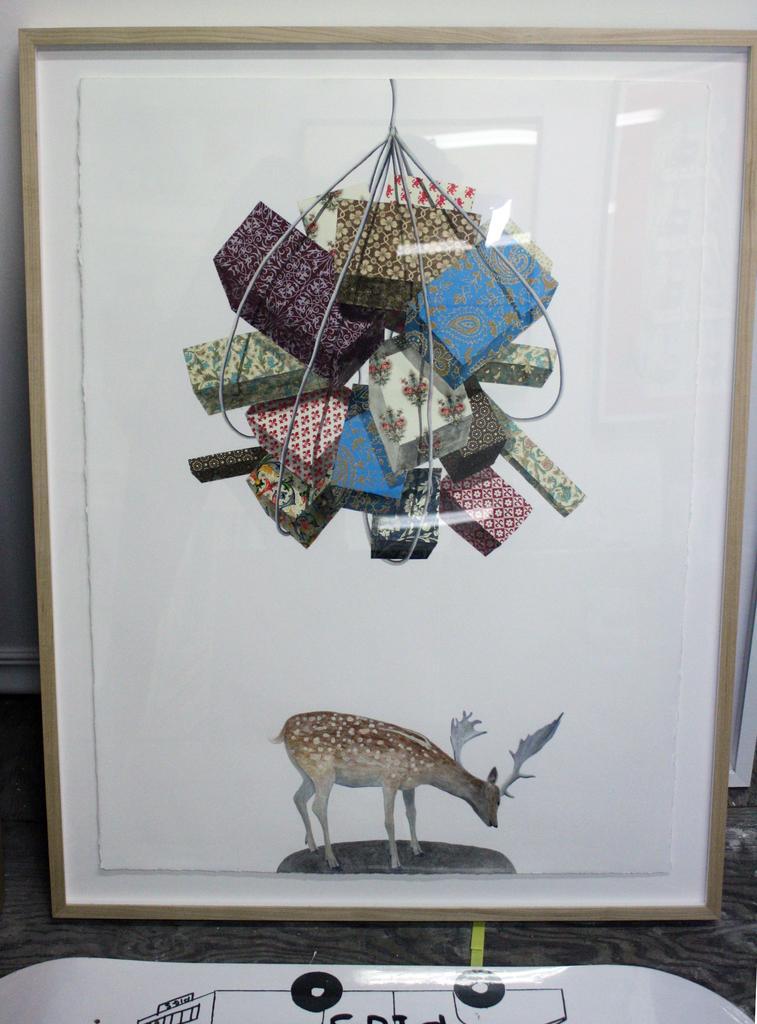Can you describe this image briefly? In this picture we can see the photo frame of a deer and some objects. Behind the photo frame, it looks like a wall. In front of the photo frame there is an object. 